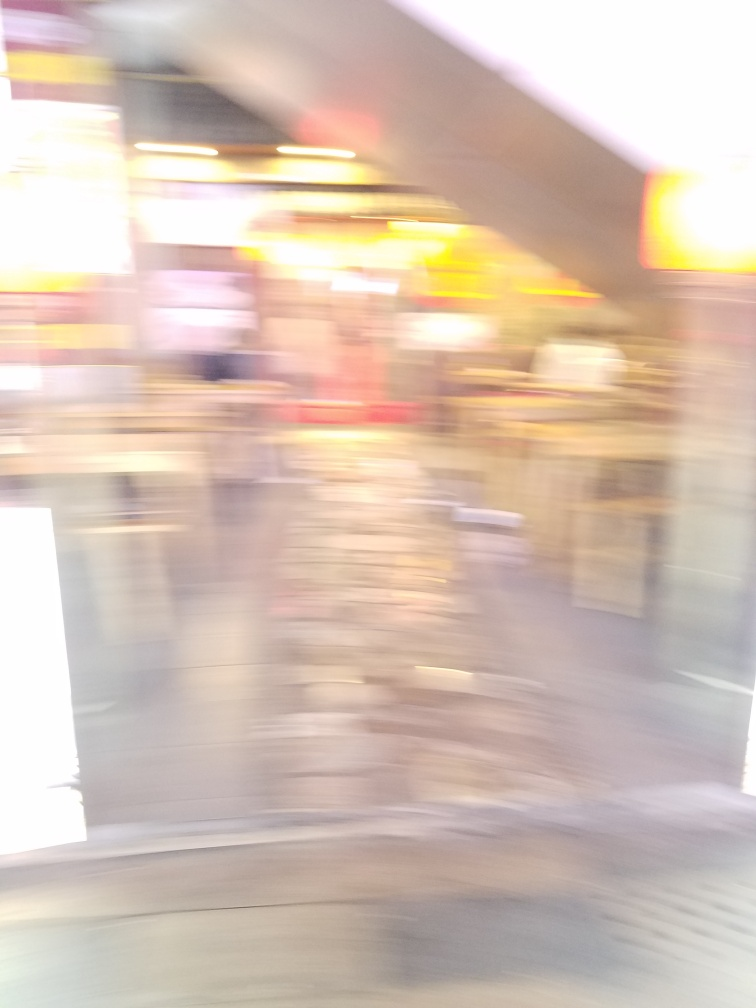What might have caused the blurriness in this photograph? The blurriness in the photograph could be due to several factors, such as camera movement during the exposure, a slow shutter speed in low light conditions, or an unintended focus error. It is suggestive of a dynamic scene, possibly captured in a hurried moment. 